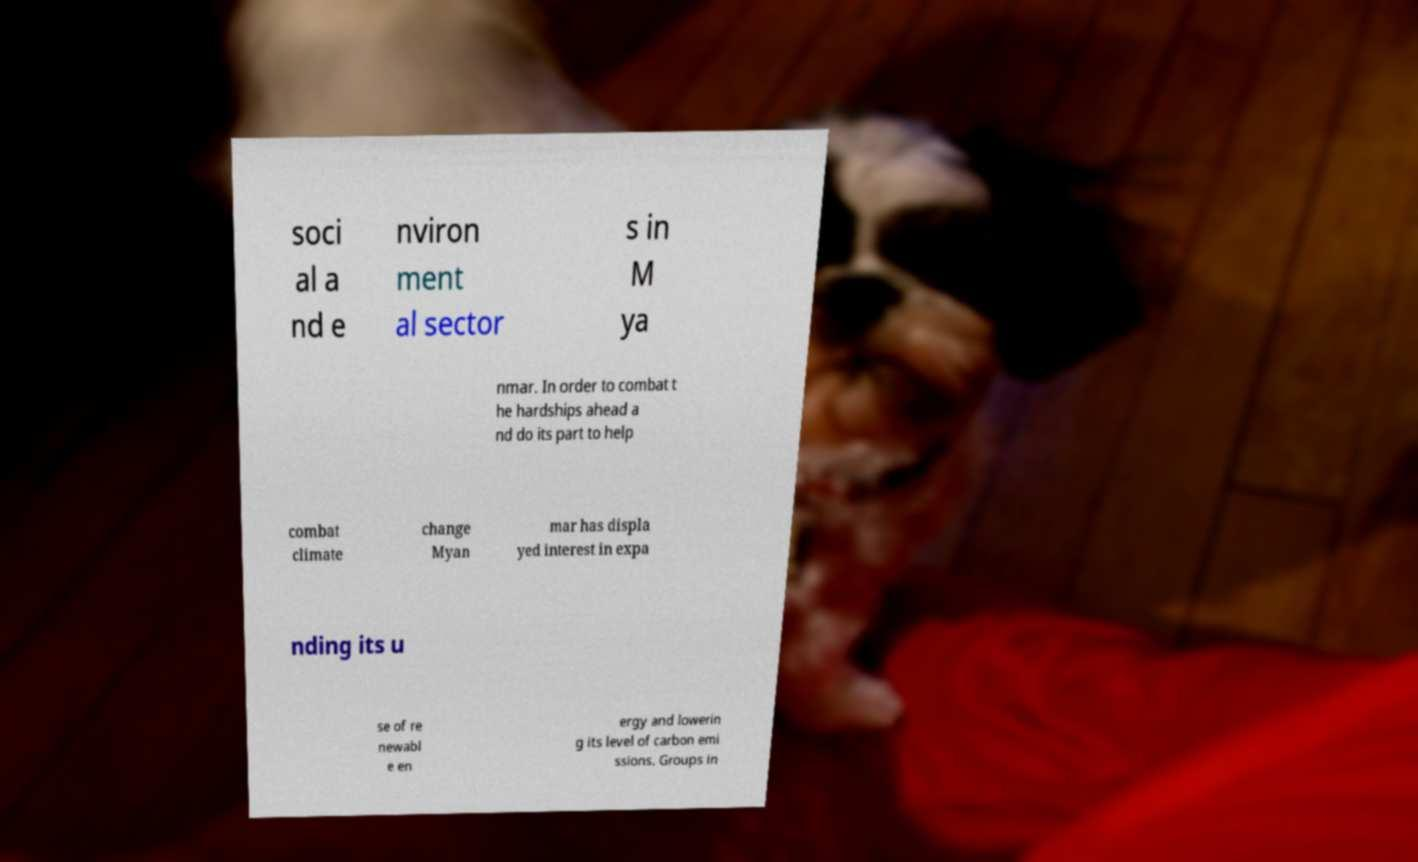Can you accurately transcribe the text from the provided image for me? soci al a nd e nviron ment al sector s in M ya nmar. In order to combat t he hardships ahead a nd do its part to help combat climate change Myan mar has displa yed interest in expa nding its u se of re newabl e en ergy and lowerin g its level of carbon emi ssions. Groups in 